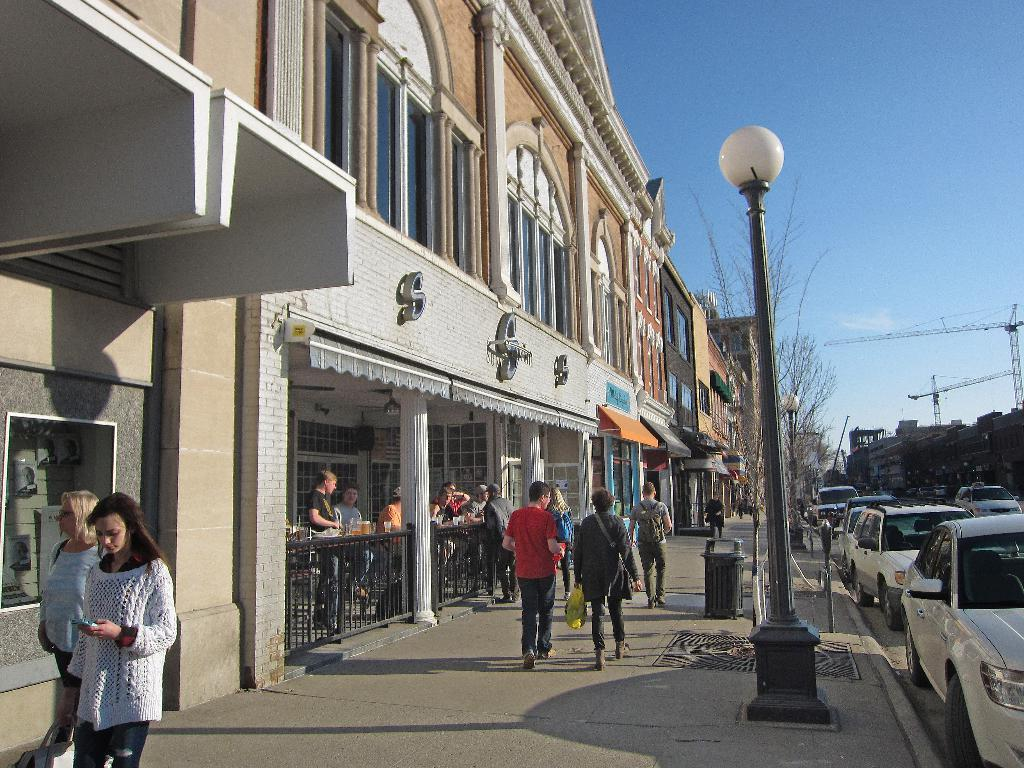What are the people in the image doing? The people in the image are walking on the pavement. What can be seen on the right side of the image? There are cars on the right side of the image. What is located on the left side of the image? There is a building on the left side of the image. What are the people near the building doing? People are standing near the building. Is there any quicksand in the image? No, there is no quicksand present in the image. Can you see a bat flying in the image? No, there is no bat visible in the image. 